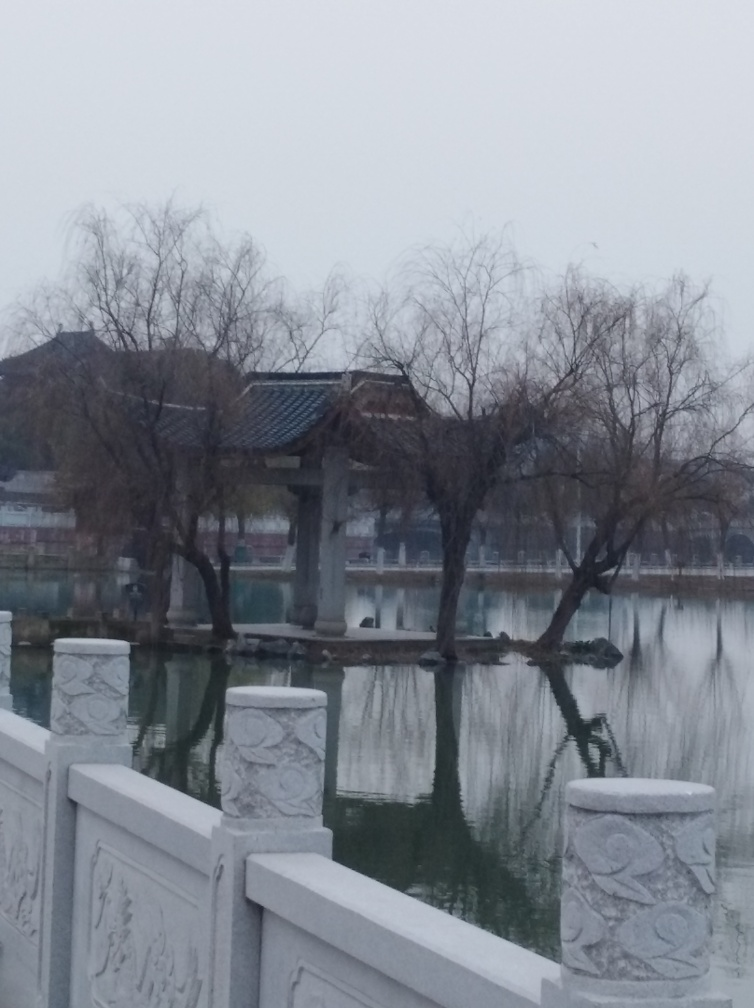What could be the function of the bridge seen in the image? The bridge in the image appears to be a pedestrian walkway, most likely intended for visitors to traverse from one side of the water to another. Its position and size suggest it is part of a park or garden, possibly designed for leisurely strolls and to offer picturesque views of the surrounding waters and landscape. 